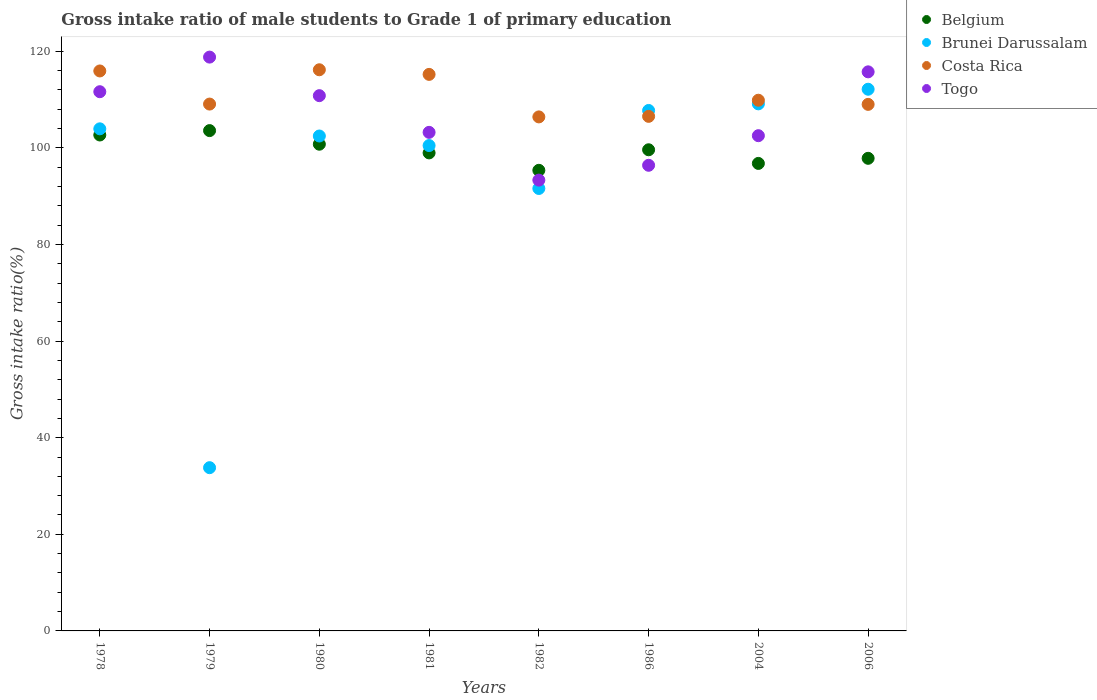Is the number of dotlines equal to the number of legend labels?
Ensure brevity in your answer.  Yes. What is the gross intake ratio in Costa Rica in 1979?
Your answer should be very brief. 109.07. Across all years, what is the maximum gross intake ratio in Belgium?
Make the answer very short. 103.58. Across all years, what is the minimum gross intake ratio in Costa Rica?
Give a very brief answer. 106.41. What is the total gross intake ratio in Togo in the graph?
Provide a short and direct response. 852.44. What is the difference between the gross intake ratio in Brunei Darussalam in 1980 and that in 2004?
Your answer should be compact. -6.66. What is the difference between the gross intake ratio in Togo in 1979 and the gross intake ratio in Belgium in 1986?
Your answer should be compact. 19.19. What is the average gross intake ratio in Togo per year?
Offer a terse response. 106.55. In the year 1979, what is the difference between the gross intake ratio in Togo and gross intake ratio in Brunei Darussalam?
Give a very brief answer. 85. What is the ratio of the gross intake ratio in Belgium in 1986 to that in 2004?
Give a very brief answer. 1.03. Is the difference between the gross intake ratio in Togo in 1982 and 2004 greater than the difference between the gross intake ratio in Brunei Darussalam in 1982 and 2004?
Provide a succinct answer. Yes. What is the difference between the highest and the second highest gross intake ratio in Togo?
Offer a terse response. 3.05. What is the difference between the highest and the lowest gross intake ratio in Brunei Darussalam?
Your response must be concise. 78.34. In how many years, is the gross intake ratio in Costa Rica greater than the average gross intake ratio in Costa Rica taken over all years?
Offer a very short reply. 3. Is the sum of the gross intake ratio in Costa Rica in 1979 and 1986 greater than the maximum gross intake ratio in Brunei Darussalam across all years?
Offer a very short reply. Yes. Is it the case that in every year, the sum of the gross intake ratio in Belgium and gross intake ratio in Togo  is greater than the sum of gross intake ratio in Brunei Darussalam and gross intake ratio in Costa Rica?
Offer a terse response. No. Does the gross intake ratio in Belgium monotonically increase over the years?
Your response must be concise. No. Is the gross intake ratio in Brunei Darussalam strictly less than the gross intake ratio in Belgium over the years?
Provide a short and direct response. No. How many dotlines are there?
Provide a short and direct response. 4. What is the difference between two consecutive major ticks on the Y-axis?
Provide a short and direct response. 20. What is the title of the graph?
Provide a succinct answer. Gross intake ratio of male students to Grade 1 of primary education. What is the label or title of the Y-axis?
Give a very brief answer. Gross intake ratio(%). What is the Gross intake ratio(%) of Belgium in 1978?
Your response must be concise. 102.67. What is the Gross intake ratio(%) of Brunei Darussalam in 1978?
Your answer should be very brief. 103.94. What is the Gross intake ratio(%) in Costa Rica in 1978?
Your answer should be very brief. 115.93. What is the Gross intake ratio(%) of Togo in 1978?
Provide a short and direct response. 111.63. What is the Gross intake ratio(%) of Belgium in 1979?
Offer a very short reply. 103.58. What is the Gross intake ratio(%) in Brunei Darussalam in 1979?
Give a very brief answer. 33.8. What is the Gross intake ratio(%) in Costa Rica in 1979?
Make the answer very short. 109.07. What is the Gross intake ratio(%) of Togo in 1979?
Your response must be concise. 118.79. What is the Gross intake ratio(%) in Belgium in 1980?
Provide a short and direct response. 100.76. What is the Gross intake ratio(%) of Brunei Darussalam in 1980?
Your response must be concise. 102.46. What is the Gross intake ratio(%) of Costa Rica in 1980?
Keep it short and to the point. 116.17. What is the Gross intake ratio(%) in Togo in 1980?
Offer a terse response. 110.81. What is the Gross intake ratio(%) in Belgium in 1981?
Offer a terse response. 98.96. What is the Gross intake ratio(%) of Brunei Darussalam in 1981?
Your answer should be compact. 100.48. What is the Gross intake ratio(%) in Costa Rica in 1981?
Your answer should be compact. 115.21. What is the Gross intake ratio(%) of Togo in 1981?
Keep it short and to the point. 103.21. What is the Gross intake ratio(%) of Belgium in 1982?
Offer a terse response. 95.36. What is the Gross intake ratio(%) in Brunei Darussalam in 1982?
Ensure brevity in your answer.  91.6. What is the Gross intake ratio(%) of Costa Rica in 1982?
Offer a very short reply. 106.41. What is the Gross intake ratio(%) in Togo in 1982?
Provide a short and direct response. 93.33. What is the Gross intake ratio(%) of Belgium in 1986?
Make the answer very short. 99.61. What is the Gross intake ratio(%) of Brunei Darussalam in 1986?
Your response must be concise. 107.75. What is the Gross intake ratio(%) of Costa Rica in 1986?
Give a very brief answer. 106.53. What is the Gross intake ratio(%) in Togo in 1986?
Your answer should be compact. 96.4. What is the Gross intake ratio(%) in Belgium in 2004?
Provide a succinct answer. 96.78. What is the Gross intake ratio(%) in Brunei Darussalam in 2004?
Keep it short and to the point. 109.11. What is the Gross intake ratio(%) of Costa Rica in 2004?
Your answer should be very brief. 109.86. What is the Gross intake ratio(%) of Togo in 2004?
Offer a terse response. 102.52. What is the Gross intake ratio(%) of Belgium in 2006?
Offer a very short reply. 97.84. What is the Gross intake ratio(%) in Brunei Darussalam in 2006?
Offer a very short reply. 112.14. What is the Gross intake ratio(%) in Costa Rica in 2006?
Make the answer very short. 109.01. What is the Gross intake ratio(%) of Togo in 2006?
Ensure brevity in your answer.  115.74. Across all years, what is the maximum Gross intake ratio(%) in Belgium?
Offer a very short reply. 103.58. Across all years, what is the maximum Gross intake ratio(%) in Brunei Darussalam?
Ensure brevity in your answer.  112.14. Across all years, what is the maximum Gross intake ratio(%) of Costa Rica?
Ensure brevity in your answer.  116.17. Across all years, what is the maximum Gross intake ratio(%) of Togo?
Provide a short and direct response. 118.79. Across all years, what is the minimum Gross intake ratio(%) in Belgium?
Your response must be concise. 95.36. Across all years, what is the minimum Gross intake ratio(%) in Brunei Darussalam?
Provide a succinct answer. 33.8. Across all years, what is the minimum Gross intake ratio(%) in Costa Rica?
Offer a terse response. 106.41. Across all years, what is the minimum Gross intake ratio(%) of Togo?
Offer a terse response. 93.33. What is the total Gross intake ratio(%) of Belgium in the graph?
Provide a short and direct response. 795.55. What is the total Gross intake ratio(%) in Brunei Darussalam in the graph?
Provide a succinct answer. 761.27. What is the total Gross intake ratio(%) of Costa Rica in the graph?
Your answer should be compact. 888.19. What is the total Gross intake ratio(%) of Togo in the graph?
Your answer should be compact. 852.44. What is the difference between the Gross intake ratio(%) of Belgium in 1978 and that in 1979?
Your answer should be compact. -0.91. What is the difference between the Gross intake ratio(%) in Brunei Darussalam in 1978 and that in 1979?
Your response must be concise. 70.15. What is the difference between the Gross intake ratio(%) of Costa Rica in 1978 and that in 1979?
Ensure brevity in your answer.  6.86. What is the difference between the Gross intake ratio(%) of Togo in 1978 and that in 1979?
Offer a terse response. -7.17. What is the difference between the Gross intake ratio(%) in Belgium in 1978 and that in 1980?
Offer a very short reply. 1.91. What is the difference between the Gross intake ratio(%) in Brunei Darussalam in 1978 and that in 1980?
Your answer should be very brief. 1.49. What is the difference between the Gross intake ratio(%) of Costa Rica in 1978 and that in 1980?
Your answer should be very brief. -0.25. What is the difference between the Gross intake ratio(%) of Togo in 1978 and that in 1980?
Your response must be concise. 0.82. What is the difference between the Gross intake ratio(%) in Belgium in 1978 and that in 1981?
Provide a succinct answer. 3.71. What is the difference between the Gross intake ratio(%) in Brunei Darussalam in 1978 and that in 1981?
Your answer should be very brief. 3.46. What is the difference between the Gross intake ratio(%) in Costa Rica in 1978 and that in 1981?
Provide a short and direct response. 0.71. What is the difference between the Gross intake ratio(%) in Togo in 1978 and that in 1981?
Your response must be concise. 8.41. What is the difference between the Gross intake ratio(%) of Belgium in 1978 and that in 1982?
Provide a succinct answer. 7.31. What is the difference between the Gross intake ratio(%) in Brunei Darussalam in 1978 and that in 1982?
Your answer should be compact. 12.35. What is the difference between the Gross intake ratio(%) in Costa Rica in 1978 and that in 1982?
Your answer should be compact. 9.51. What is the difference between the Gross intake ratio(%) of Togo in 1978 and that in 1982?
Your response must be concise. 18.3. What is the difference between the Gross intake ratio(%) of Belgium in 1978 and that in 1986?
Keep it short and to the point. 3.06. What is the difference between the Gross intake ratio(%) in Brunei Darussalam in 1978 and that in 1986?
Offer a terse response. -3.8. What is the difference between the Gross intake ratio(%) of Costa Rica in 1978 and that in 1986?
Your answer should be very brief. 9.4. What is the difference between the Gross intake ratio(%) of Togo in 1978 and that in 1986?
Offer a very short reply. 15.23. What is the difference between the Gross intake ratio(%) of Belgium in 1978 and that in 2004?
Your answer should be compact. 5.89. What is the difference between the Gross intake ratio(%) of Brunei Darussalam in 1978 and that in 2004?
Ensure brevity in your answer.  -5.17. What is the difference between the Gross intake ratio(%) in Costa Rica in 1978 and that in 2004?
Keep it short and to the point. 6.06. What is the difference between the Gross intake ratio(%) of Togo in 1978 and that in 2004?
Ensure brevity in your answer.  9.1. What is the difference between the Gross intake ratio(%) of Belgium in 1978 and that in 2006?
Make the answer very short. 4.83. What is the difference between the Gross intake ratio(%) of Brunei Darussalam in 1978 and that in 2006?
Ensure brevity in your answer.  -8.2. What is the difference between the Gross intake ratio(%) in Costa Rica in 1978 and that in 2006?
Provide a short and direct response. 6.92. What is the difference between the Gross intake ratio(%) in Togo in 1978 and that in 2006?
Offer a very short reply. -4.11. What is the difference between the Gross intake ratio(%) in Belgium in 1979 and that in 1980?
Ensure brevity in your answer.  2.82. What is the difference between the Gross intake ratio(%) of Brunei Darussalam in 1979 and that in 1980?
Your answer should be very brief. -68.66. What is the difference between the Gross intake ratio(%) of Costa Rica in 1979 and that in 1980?
Make the answer very short. -7.1. What is the difference between the Gross intake ratio(%) in Togo in 1979 and that in 1980?
Offer a very short reply. 7.98. What is the difference between the Gross intake ratio(%) in Belgium in 1979 and that in 1981?
Your answer should be compact. 4.61. What is the difference between the Gross intake ratio(%) of Brunei Darussalam in 1979 and that in 1981?
Make the answer very short. -66.69. What is the difference between the Gross intake ratio(%) in Costa Rica in 1979 and that in 1981?
Your response must be concise. -6.14. What is the difference between the Gross intake ratio(%) of Togo in 1979 and that in 1981?
Make the answer very short. 15.58. What is the difference between the Gross intake ratio(%) in Belgium in 1979 and that in 1982?
Your response must be concise. 8.22. What is the difference between the Gross intake ratio(%) in Brunei Darussalam in 1979 and that in 1982?
Offer a terse response. -57.8. What is the difference between the Gross intake ratio(%) of Costa Rica in 1979 and that in 1982?
Ensure brevity in your answer.  2.66. What is the difference between the Gross intake ratio(%) in Togo in 1979 and that in 1982?
Your response must be concise. 25.47. What is the difference between the Gross intake ratio(%) in Belgium in 1979 and that in 1986?
Your response must be concise. 3.97. What is the difference between the Gross intake ratio(%) of Brunei Darussalam in 1979 and that in 1986?
Give a very brief answer. -73.95. What is the difference between the Gross intake ratio(%) in Costa Rica in 1979 and that in 1986?
Offer a very short reply. 2.54. What is the difference between the Gross intake ratio(%) in Togo in 1979 and that in 1986?
Your answer should be very brief. 22.4. What is the difference between the Gross intake ratio(%) in Belgium in 1979 and that in 2004?
Offer a very short reply. 6.79. What is the difference between the Gross intake ratio(%) in Brunei Darussalam in 1979 and that in 2004?
Provide a short and direct response. -75.32. What is the difference between the Gross intake ratio(%) of Costa Rica in 1979 and that in 2004?
Your answer should be compact. -0.8. What is the difference between the Gross intake ratio(%) in Togo in 1979 and that in 2004?
Provide a succinct answer. 16.27. What is the difference between the Gross intake ratio(%) of Belgium in 1979 and that in 2006?
Give a very brief answer. 5.74. What is the difference between the Gross intake ratio(%) of Brunei Darussalam in 1979 and that in 2006?
Your response must be concise. -78.34. What is the difference between the Gross intake ratio(%) of Costa Rica in 1979 and that in 2006?
Make the answer very short. 0.06. What is the difference between the Gross intake ratio(%) of Togo in 1979 and that in 2006?
Make the answer very short. 3.05. What is the difference between the Gross intake ratio(%) of Belgium in 1980 and that in 1981?
Give a very brief answer. 1.8. What is the difference between the Gross intake ratio(%) of Brunei Darussalam in 1980 and that in 1981?
Provide a short and direct response. 1.98. What is the difference between the Gross intake ratio(%) in Costa Rica in 1980 and that in 1981?
Offer a terse response. 0.96. What is the difference between the Gross intake ratio(%) in Togo in 1980 and that in 1981?
Your response must be concise. 7.6. What is the difference between the Gross intake ratio(%) of Belgium in 1980 and that in 1982?
Provide a succinct answer. 5.4. What is the difference between the Gross intake ratio(%) of Brunei Darussalam in 1980 and that in 1982?
Offer a very short reply. 10.86. What is the difference between the Gross intake ratio(%) in Costa Rica in 1980 and that in 1982?
Make the answer very short. 9.76. What is the difference between the Gross intake ratio(%) of Togo in 1980 and that in 1982?
Make the answer very short. 17.49. What is the difference between the Gross intake ratio(%) in Belgium in 1980 and that in 1986?
Your answer should be compact. 1.15. What is the difference between the Gross intake ratio(%) in Brunei Darussalam in 1980 and that in 1986?
Give a very brief answer. -5.29. What is the difference between the Gross intake ratio(%) of Costa Rica in 1980 and that in 1986?
Keep it short and to the point. 9.64. What is the difference between the Gross intake ratio(%) in Togo in 1980 and that in 1986?
Offer a terse response. 14.41. What is the difference between the Gross intake ratio(%) of Belgium in 1980 and that in 2004?
Keep it short and to the point. 3.98. What is the difference between the Gross intake ratio(%) in Brunei Darussalam in 1980 and that in 2004?
Offer a terse response. -6.66. What is the difference between the Gross intake ratio(%) of Costa Rica in 1980 and that in 2004?
Provide a short and direct response. 6.31. What is the difference between the Gross intake ratio(%) of Togo in 1980 and that in 2004?
Offer a terse response. 8.29. What is the difference between the Gross intake ratio(%) in Belgium in 1980 and that in 2006?
Make the answer very short. 2.92. What is the difference between the Gross intake ratio(%) in Brunei Darussalam in 1980 and that in 2006?
Give a very brief answer. -9.68. What is the difference between the Gross intake ratio(%) in Costa Rica in 1980 and that in 2006?
Provide a short and direct response. 7.16. What is the difference between the Gross intake ratio(%) in Togo in 1980 and that in 2006?
Make the answer very short. -4.93. What is the difference between the Gross intake ratio(%) of Belgium in 1981 and that in 1982?
Make the answer very short. 3.61. What is the difference between the Gross intake ratio(%) in Brunei Darussalam in 1981 and that in 1982?
Keep it short and to the point. 8.89. What is the difference between the Gross intake ratio(%) in Costa Rica in 1981 and that in 1982?
Your answer should be compact. 8.8. What is the difference between the Gross intake ratio(%) in Togo in 1981 and that in 1982?
Offer a terse response. 9.89. What is the difference between the Gross intake ratio(%) in Belgium in 1981 and that in 1986?
Give a very brief answer. -0.65. What is the difference between the Gross intake ratio(%) of Brunei Darussalam in 1981 and that in 1986?
Your answer should be compact. -7.27. What is the difference between the Gross intake ratio(%) of Costa Rica in 1981 and that in 1986?
Your answer should be compact. 8.69. What is the difference between the Gross intake ratio(%) of Togo in 1981 and that in 1986?
Your answer should be very brief. 6.82. What is the difference between the Gross intake ratio(%) of Belgium in 1981 and that in 2004?
Make the answer very short. 2.18. What is the difference between the Gross intake ratio(%) in Brunei Darussalam in 1981 and that in 2004?
Provide a succinct answer. -8.63. What is the difference between the Gross intake ratio(%) in Costa Rica in 1981 and that in 2004?
Offer a very short reply. 5.35. What is the difference between the Gross intake ratio(%) of Togo in 1981 and that in 2004?
Your answer should be compact. 0.69. What is the difference between the Gross intake ratio(%) of Belgium in 1981 and that in 2006?
Offer a terse response. 1.12. What is the difference between the Gross intake ratio(%) of Brunei Darussalam in 1981 and that in 2006?
Make the answer very short. -11.66. What is the difference between the Gross intake ratio(%) of Costa Rica in 1981 and that in 2006?
Provide a succinct answer. 6.21. What is the difference between the Gross intake ratio(%) in Togo in 1981 and that in 2006?
Give a very brief answer. -12.53. What is the difference between the Gross intake ratio(%) in Belgium in 1982 and that in 1986?
Keep it short and to the point. -4.25. What is the difference between the Gross intake ratio(%) in Brunei Darussalam in 1982 and that in 1986?
Your answer should be compact. -16.15. What is the difference between the Gross intake ratio(%) in Costa Rica in 1982 and that in 1986?
Your response must be concise. -0.11. What is the difference between the Gross intake ratio(%) of Togo in 1982 and that in 1986?
Offer a very short reply. -3.07. What is the difference between the Gross intake ratio(%) of Belgium in 1982 and that in 2004?
Give a very brief answer. -1.43. What is the difference between the Gross intake ratio(%) of Brunei Darussalam in 1982 and that in 2004?
Your answer should be compact. -17.52. What is the difference between the Gross intake ratio(%) of Costa Rica in 1982 and that in 2004?
Your answer should be compact. -3.45. What is the difference between the Gross intake ratio(%) of Togo in 1982 and that in 2004?
Ensure brevity in your answer.  -9.2. What is the difference between the Gross intake ratio(%) in Belgium in 1982 and that in 2006?
Your answer should be very brief. -2.48. What is the difference between the Gross intake ratio(%) in Brunei Darussalam in 1982 and that in 2006?
Give a very brief answer. -20.55. What is the difference between the Gross intake ratio(%) of Costa Rica in 1982 and that in 2006?
Keep it short and to the point. -2.59. What is the difference between the Gross intake ratio(%) of Togo in 1982 and that in 2006?
Your answer should be very brief. -22.42. What is the difference between the Gross intake ratio(%) in Belgium in 1986 and that in 2004?
Your answer should be very brief. 2.82. What is the difference between the Gross intake ratio(%) in Brunei Darussalam in 1986 and that in 2004?
Make the answer very short. -1.37. What is the difference between the Gross intake ratio(%) in Costa Rica in 1986 and that in 2004?
Ensure brevity in your answer.  -3.34. What is the difference between the Gross intake ratio(%) of Togo in 1986 and that in 2004?
Provide a succinct answer. -6.13. What is the difference between the Gross intake ratio(%) in Belgium in 1986 and that in 2006?
Your answer should be very brief. 1.77. What is the difference between the Gross intake ratio(%) of Brunei Darussalam in 1986 and that in 2006?
Make the answer very short. -4.39. What is the difference between the Gross intake ratio(%) of Costa Rica in 1986 and that in 2006?
Keep it short and to the point. -2.48. What is the difference between the Gross intake ratio(%) of Togo in 1986 and that in 2006?
Your answer should be compact. -19.34. What is the difference between the Gross intake ratio(%) of Belgium in 2004 and that in 2006?
Give a very brief answer. -1.06. What is the difference between the Gross intake ratio(%) of Brunei Darussalam in 2004 and that in 2006?
Your answer should be very brief. -3.03. What is the difference between the Gross intake ratio(%) in Costa Rica in 2004 and that in 2006?
Your answer should be compact. 0.86. What is the difference between the Gross intake ratio(%) of Togo in 2004 and that in 2006?
Make the answer very short. -13.22. What is the difference between the Gross intake ratio(%) in Belgium in 1978 and the Gross intake ratio(%) in Brunei Darussalam in 1979?
Keep it short and to the point. 68.87. What is the difference between the Gross intake ratio(%) of Belgium in 1978 and the Gross intake ratio(%) of Costa Rica in 1979?
Offer a terse response. -6.4. What is the difference between the Gross intake ratio(%) of Belgium in 1978 and the Gross intake ratio(%) of Togo in 1979?
Ensure brevity in your answer.  -16.12. What is the difference between the Gross intake ratio(%) in Brunei Darussalam in 1978 and the Gross intake ratio(%) in Costa Rica in 1979?
Your response must be concise. -5.13. What is the difference between the Gross intake ratio(%) of Brunei Darussalam in 1978 and the Gross intake ratio(%) of Togo in 1979?
Offer a very short reply. -14.85. What is the difference between the Gross intake ratio(%) of Costa Rica in 1978 and the Gross intake ratio(%) of Togo in 1979?
Offer a very short reply. -2.87. What is the difference between the Gross intake ratio(%) of Belgium in 1978 and the Gross intake ratio(%) of Brunei Darussalam in 1980?
Keep it short and to the point. 0.21. What is the difference between the Gross intake ratio(%) in Belgium in 1978 and the Gross intake ratio(%) in Costa Rica in 1980?
Keep it short and to the point. -13.5. What is the difference between the Gross intake ratio(%) of Belgium in 1978 and the Gross intake ratio(%) of Togo in 1980?
Provide a short and direct response. -8.14. What is the difference between the Gross intake ratio(%) in Brunei Darussalam in 1978 and the Gross intake ratio(%) in Costa Rica in 1980?
Offer a terse response. -12.23. What is the difference between the Gross intake ratio(%) of Brunei Darussalam in 1978 and the Gross intake ratio(%) of Togo in 1980?
Offer a very short reply. -6.87. What is the difference between the Gross intake ratio(%) of Costa Rica in 1978 and the Gross intake ratio(%) of Togo in 1980?
Make the answer very short. 5.11. What is the difference between the Gross intake ratio(%) in Belgium in 1978 and the Gross intake ratio(%) in Brunei Darussalam in 1981?
Keep it short and to the point. 2.19. What is the difference between the Gross intake ratio(%) of Belgium in 1978 and the Gross intake ratio(%) of Costa Rica in 1981?
Your answer should be compact. -12.55. What is the difference between the Gross intake ratio(%) of Belgium in 1978 and the Gross intake ratio(%) of Togo in 1981?
Your answer should be very brief. -0.55. What is the difference between the Gross intake ratio(%) in Brunei Darussalam in 1978 and the Gross intake ratio(%) in Costa Rica in 1981?
Your answer should be compact. -11.27. What is the difference between the Gross intake ratio(%) of Brunei Darussalam in 1978 and the Gross intake ratio(%) of Togo in 1981?
Your response must be concise. 0.73. What is the difference between the Gross intake ratio(%) in Costa Rica in 1978 and the Gross intake ratio(%) in Togo in 1981?
Offer a very short reply. 12.71. What is the difference between the Gross intake ratio(%) in Belgium in 1978 and the Gross intake ratio(%) in Brunei Darussalam in 1982?
Give a very brief answer. 11.07. What is the difference between the Gross intake ratio(%) of Belgium in 1978 and the Gross intake ratio(%) of Costa Rica in 1982?
Provide a succinct answer. -3.74. What is the difference between the Gross intake ratio(%) in Belgium in 1978 and the Gross intake ratio(%) in Togo in 1982?
Give a very brief answer. 9.34. What is the difference between the Gross intake ratio(%) of Brunei Darussalam in 1978 and the Gross intake ratio(%) of Costa Rica in 1982?
Offer a terse response. -2.47. What is the difference between the Gross intake ratio(%) in Brunei Darussalam in 1978 and the Gross intake ratio(%) in Togo in 1982?
Provide a succinct answer. 10.62. What is the difference between the Gross intake ratio(%) in Costa Rica in 1978 and the Gross intake ratio(%) in Togo in 1982?
Keep it short and to the point. 22.6. What is the difference between the Gross intake ratio(%) of Belgium in 1978 and the Gross intake ratio(%) of Brunei Darussalam in 1986?
Make the answer very short. -5.08. What is the difference between the Gross intake ratio(%) of Belgium in 1978 and the Gross intake ratio(%) of Costa Rica in 1986?
Your answer should be compact. -3.86. What is the difference between the Gross intake ratio(%) in Belgium in 1978 and the Gross intake ratio(%) in Togo in 1986?
Your answer should be compact. 6.27. What is the difference between the Gross intake ratio(%) in Brunei Darussalam in 1978 and the Gross intake ratio(%) in Costa Rica in 1986?
Your answer should be very brief. -2.58. What is the difference between the Gross intake ratio(%) in Brunei Darussalam in 1978 and the Gross intake ratio(%) in Togo in 1986?
Your answer should be very brief. 7.55. What is the difference between the Gross intake ratio(%) of Costa Rica in 1978 and the Gross intake ratio(%) of Togo in 1986?
Provide a succinct answer. 19.53. What is the difference between the Gross intake ratio(%) in Belgium in 1978 and the Gross intake ratio(%) in Brunei Darussalam in 2004?
Offer a very short reply. -6.44. What is the difference between the Gross intake ratio(%) of Belgium in 1978 and the Gross intake ratio(%) of Costa Rica in 2004?
Provide a short and direct response. -7.2. What is the difference between the Gross intake ratio(%) of Belgium in 1978 and the Gross intake ratio(%) of Togo in 2004?
Give a very brief answer. 0.14. What is the difference between the Gross intake ratio(%) in Brunei Darussalam in 1978 and the Gross intake ratio(%) in Costa Rica in 2004?
Ensure brevity in your answer.  -5.92. What is the difference between the Gross intake ratio(%) in Brunei Darussalam in 1978 and the Gross intake ratio(%) in Togo in 2004?
Your answer should be compact. 1.42. What is the difference between the Gross intake ratio(%) in Costa Rica in 1978 and the Gross intake ratio(%) in Togo in 2004?
Offer a very short reply. 13.4. What is the difference between the Gross intake ratio(%) in Belgium in 1978 and the Gross intake ratio(%) in Brunei Darussalam in 2006?
Keep it short and to the point. -9.47. What is the difference between the Gross intake ratio(%) in Belgium in 1978 and the Gross intake ratio(%) in Costa Rica in 2006?
Your answer should be compact. -6.34. What is the difference between the Gross intake ratio(%) in Belgium in 1978 and the Gross intake ratio(%) in Togo in 2006?
Your answer should be very brief. -13.07. What is the difference between the Gross intake ratio(%) in Brunei Darussalam in 1978 and the Gross intake ratio(%) in Costa Rica in 2006?
Your response must be concise. -5.06. What is the difference between the Gross intake ratio(%) of Brunei Darussalam in 1978 and the Gross intake ratio(%) of Togo in 2006?
Provide a short and direct response. -11.8. What is the difference between the Gross intake ratio(%) in Costa Rica in 1978 and the Gross intake ratio(%) in Togo in 2006?
Offer a terse response. 0.18. What is the difference between the Gross intake ratio(%) of Belgium in 1979 and the Gross intake ratio(%) of Brunei Darussalam in 1980?
Provide a succinct answer. 1.12. What is the difference between the Gross intake ratio(%) of Belgium in 1979 and the Gross intake ratio(%) of Costa Rica in 1980?
Provide a succinct answer. -12.59. What is the difference between the Gross intake ratio(%) in Belgium in 1979 and the Gross intake ratio(%) in Togo in 1980?
Provide a short and direct response. -7.23. What is the difference between the Gross intake ratio(%) of Brunei Darussalam in 1979 and the Gross intake ratio(%) of Costa Rica in 1980?
Offer a very short reply. -82.38. What is the difference between the Gross intake ratio(%) in Brunei Darussalam in 1979 and the Gross intake ratio(%) in Togo in 1980?
Provide a short and direct response. -77.02. What is the difference between the Gross intake ratio(%) in Costa Rica in 1979 and the Gross intake ratio(%) in Togo in 1980?
Offer a very short reply. -1.74. What is the difference between the Gross intake ratio(%) in Belgium in 1979 and the Gross intake ratio(%) in Brunei Darussalam in 1981?
Give a very brief answer. 3.1. What is the difference between the Gross intake ratio(%) of Belgium in 1979 and the Gross intake ratio(%) of Costa Rica in 1981?
Offer a terse response. -11.64. What is the difference between the Gross intake ratio(%) in Belgium in 1979 and the Gross intake ratio(%) in Togo in 1981?
Offer a terse response. 0.36. What is the difference between the Gross intake ratio(%) of Brunei Darussalam in 1979 and the Gross intake ratio(%) of Costa Rica in 1981?
Make the answer very short. -81.42. What is the difference between the Gross intake ratio(%) of Brunei Darussalam in 1979 and the Gross intake ratio(%) of Togo in 1981?
Keep it short and to the point. -69.42. What is the difference between the Gross intake ratio(%) in Costa Rica in 1979 and the Gross intake ratio(%) in Togo in 1981?
Ensure brevity in your answer.  5.85. What is the difference between the Gross intake ratio(%) of Belgium in 1979 and the Gross intake ratio(%) of Brunei Darussalam in 1982?
Your answer should be very brief. 11.98. What is the difference between the Gross intake ratio(%) of Belgium in 1979 and the Gross intake ratio(%) of Costa Rica in 1982?
Provide a succinct answer. -2.84. What is the difference between the Gross intake ratio(%) of Belgium in 1979 and the Gross intake ratio(%) of Togo in 1982?
Make the answer very short. 10.25. What is the difference between the Gross intake ratio(%) of Brunei Darussalam in 1979 and the Gross intake ratio(%) of Costa Rica in 1982?
Offer a terse response. -72.62. What is the difference between the Gross intake ratio(%) in Brunei Darussalam in 1979 and the Gross intake ratio(%) in Togo in 1982?
Make the answer very short. -59.53. What is the difference between the Gross intake ratio(%) of Costa Rica in 1979 and the Gross intake ratio(%) of Togo in 1982?
Your answer should be very brief. 15.74. What is the difference between the Gross intake ratio(%) in Belgium in 1979 and the Gross intake ratio(%) in Brunei Darussalam in 1986?
Your answer should be compact. -4.17. What is the difference between the Gross intake ratio(%) of Belgium in 1979 and the Gross intake ratio(%) of Costa Rica in 1986?
Ensure brevity in your answer.  -2.95. What is the difference between the Gross intake ratio(%) in Belgium in 1979 and the Gross intake ratio(%) in Togo in 1986?
Provide a succinct answer. 7.18. What is the difference between the Gross intake ratio(%) in Brunei Darussalam in 1979 and the Gross intake ratio(%) in Costa Rica in 1986?
Offer a terse response. -72.73. What is the difference between the Gross intake ratio(%) in Brunei Darussalam in 1979 and the Gross intake ratio(%) in Togo in 1986?
Your answer should be compact. -62.6. What is the difference between the Gross intake ratio(%) of Costa Rica in 1979 and the Gross intake ratio(%) of Togo in 1986?
Provide a succinct answer. 12.67. What is the difference between the Gross intake ratio(%) in Belgium in 1979 and the Gross intake ratio(%) in Brunei Darussalam in 2004?
Your answer should be very brief. -5.54. What is the difference between the Gross intake ratio(%) in Belgium in 1979 and the Gross intake ratio(%) in Costa Rica in 2004?
Give a very brief answer. -6.29. What is the difference between the Gross intake ratio(%) in Belgium in 1979 and the Gross intake ratio(%) in Togo in 2004?
Provide a short and direct response. 1.05. What is the difference between the Gross intake ratio(%) of Brunei Darussalam in 1979 and the Gross intake ratio(%) of Costa Rica in 2004?
Provide a succinct answer. -76.07. What is the difference between the Gross intake ratio(%) of Brunei Darussalam in 1979 and the Gross intake ratio(%) of Togo in 2004?
Your response must be concise. -68.73. What is the difference between the Gross intake ratio(%) in Costa Rica in 1979 and the Gross intake ratio(%) in Togo in 2004?
Keep it short and to the point. 6.54. What is the difference between the Gross intake ratio(%) in Belgium in 1979 and the Gross intake ratio(%) in Brunei Darussalam in 2006?
Offer a very short reply. -8.56. What is the difference between the Gross intake ratio(%) of Belgium in 1979 and the Gross intake ratio(%) of Costa Rica in 2006?
Provide a short and direct response. -5.43. What is the difference between the Gross intake ratio(%) of Belgium in 1979 and the Gross intake ratio(%) of Togo in 2006?
Provide a short and direct response. -12.16. What is the difference between the Gross intake ratio(%) of Brunei Darussalam in 1979 and the Gross intake ratio(%) of Costa Rica in 2006?
Provide a succinct answer. -75.21. What is the difference between the Gross intake ratio(%) in Brunei Darussalam in 1979 and the Gross intake ratio(%) in Togo in 2006?
Your answer should be compact. -81.95. What is the difference between the Gross intake ratio(%) in Costa Rica in 1979 and the Gross intake ratio(%) in Togo in 2006?
Your answer should be very brief. -6.67. What is the difference between the Gross intake ratio(%) in Belgium in 1980 and the Gross intake ratio(%) in Brunei Darussalam in 1981?
Make the answer very short. 0.28. What is the difference between the Gross intake ratio(%) in Belgium in 1980 and the Gross intake ratio(%) in Costa Rica in 1981?
Offer a terse response. -14.45. What is the difference between the Gross intake ratio(%) of Belgium in 1980 and the Gross intake ratio(%) of Togo in 1981?
Your response must be concise. -2.46. What is the difference between the Gross intake ratio(%) of Brunei Darussalam in 1980 and the Gross intake ratio(%) of Costa Rica in 1981?
Your answer should be very brief. -12.76. What is the difference between the Gross intake ratio(%) in Brunei Darussalam in 1980 and the Gross intake ratio(%) in Togo in 1981?
Offer a terse response. -0.76. What is the difference between the Gross intake ratio(%) of Costa Rica in 1980 and the Gross intake ratio(%) of Togo in 1981?
Offer a very short reply. 12.96. What is the difference between the Gross intake ratio(%) of Belgium in 1980 and the Gross intake ratio(%) of Brunei Darussalam in 1982?
Your answer should be very brief. 9.16. What is the difference between the Gross intake ratio(%) in Belgium in 1980 and the Gross intake ratio(%) in Costa Rica in 1982?
Your answer should be very brief. -5.65. What is the difference between the Gross intake ratio(%) of Belgium in 1980 and the Gross intake ratio(%) of Togo in 1982?
Your answer should be very brief. 7.43. What is the difference between the Gross intake ratio(%) of Brunei Darussalam in 1980 and the Gross intake ratio(%) of Costa Rica in 1982?
Your answer should be very brief. -3.95. What is the difference between the Gross intake ratio(%) in Brunei Darussalam in 1980 and the Gross intake ratio(%) in Togo in 1982?
Give a very brief answer. 9.13. What is the difference between the Gross intake ratio(%) of Costa Rica in 1980 and the Gross intake ratio(%) of Togo in 1982?
Your answer should be very brief. 22.84. What is the difference between the Gross intake ratio(%) of Belgium in 1980 and the Gross intake ratio(%) of Brunei Darussalam in 1986?
Give a very brief answer. -6.99. What is the difference between the Gross intake ratio(%) of Belgium in 1980 and the Gross intake ratio(%) of Costa Rica in 1986?
Your answer should be very brief. -5.77. What is the difference between the Gross intake ratio(%) of Belgium in 1980 and the Gross intake ratio(%) of Togo in 1986?
Offer a very short reply. 4.36. What is the difference between the Gross intake ratio(%) of Brunei Darussalam in 1980 and the Gross intake ratio(%) of Costa Rica in 1986?
Give a very brief answer. -4.07. What is the difference between the Gross intake ratio(%) of Brunei Darussalam in 1980 and the Gross intake ratio(%) of Togo in 1986?
Provide a succinct answer. 6.06. What is the difference between the Gross intake ratio(%) of Costa Rica in 1980 and the Gross intake ratio(%) of Togo in 1986?
Your response must be concise. 19.77. What is the difference between the Gross intake ratio(%) of Belgium in 1980 and the Gross intake ratio(%) of Brunei Darussalam in 2004?
Keep it short and to the point. -8.35. What is the difference between the Gross intake ratio(%) in Belgium in 1980 and the Gross intake ratio(%) in Costa Rica in 2004?
Make the answer very short. -9.1. What is the difference between the Gross intake ratio(%) in Belgium in 1980 and the Gross intake ratio(%) in Togo in 2004?
Give a very brief answer. -1.76. What is the difference between the Gross intake ratio(%) in Brunei Darussalam in 1980 and the Gross intake ratio(%) in Costa Rica in 2004?
Your answer should be very brief. -7.41. What is the difference between the Gross intake ratio(%) of Brunei Darussalam in 1980 and the Gross intake ratio(%) of Togo in 2004?
Keep it short and to the point. -0.07. What is the difference between the Gross intake ratio(%) of Costa Rica in 1980 and the Gross intake ratio(%) of Togo in 2004?
Ensure brevity in your answer.  13.65. What is the difference between the Gross intake ratio(%) of Belgium in 1980 and the Gross intake ratio(%) of Brunei Darussalam in 2006?
Your response must be concise. -11.38. What is the difference between the Gross intake ratio(%) of Belgium in 1980 and the Gross intake ratio(%) of Costa Rica in 2006?
Your answer should be very brief. -8.25. What is the difference between the Gross intake ratio(%) in Belgium in 1980 and the Gross intake ratio(%) in Togo in 2006?
Your answer should be very brief. -14.98. What is the difference between the Gross intake ratio(%) of Brunei Darussalam in 1980 and the Gross intake ratio(%) of Costa Rica in 2006?
Provide a short and direct response. -6.55. What is the difference between the Gross intake ratio(%) in Brunei Darussalam in 1980 and the Gross intake ratio(%) in Togo in 2006?
Your answer should be very brief. -13.28. What is the difference between the Gross intake ratio(%) in Costa Rica in 1980 and the Gross intake ratio(%) in Togo in 2006?
Your answer should be compact. 0.43. What is the difference between the Gross intake ratio(%) in Belgium in 1981 and the Gross intake ratio(%) in Brunei Darussalam in 1982?
Make the answer very short. 7.37. What is the difference between the Gross intake ratio(%) in Belgium in 1981 and the Gross intake ratio(%) in Costa Rica in 1982?
Your response must be concise. -7.45. What is the difference between the Gross intake ratio(%) of Belgium in 1981 and the Gross intake ratio(%) of Togo in 1982?
Your answer should be compact. 5.64. What is the difference between the Gross intake ratio(%) of Brunei Darussalam in 1981 and the Gross intake ratio(%) of Costa Rica in 1982?
Your answer should be compact. -5.93. What is the difference between the Gross intake ratio(%) in Brunei Darussalam in 1981 and the Gross intake ratio(%) in Togo in 1982?
Provide a short and direct response. 7.15. What is the difference between the Gross intake ratio(%) of Costa Rica in 1981 and the Gross intake ratio(%) of Togo in 1982?
Your response must be concise. 21.89. What is the difference between the Gross intake ratio(%) in Belgium in 1981 and the Gross intake ratio(%) in Brunei Darussalam in 1986?
Provide a succinct answer. -8.78. What is the difference between the Gross intake ratio(%) in Belgium in 1981 and the Gross intake ratio(%) in Costa Rica in 1986?
Provide a succinct answer. -7.56. What is the difference between the Gross intake ratio(%) of Belgium in 1981 and the Gross intake ratio(%) of Togo in 1986?
Make the answer very short. 2.56. What is the difference between the Gross intake ratio(%) of Brunei Darussalam in 1981 and the Gross intake ratio(%) of Costa Rica in 1986?
Your answer should be very brief. -6.05. What is the difference between the Gross intake ratio(%) in Brunei Darussalam in 1981 and the Gross intake ratio(%) in Togo in 1986?
Give a very brief answer. 4.08. What is the difference between the Gross intake ratio(%) in Costa Rica in 1981 and the Gross intake ratio(%) in Togo in 1986?
Keep it short and to the point. 18.82. What is the difference between the Gross intake ratio(%) of Belgium in 1981 and the Gross intake ratio(%) of Brunei Darussalam in 2004?
Keep it short and to the point. -10.15. What is the difference between the Gross intake ratio(%) of Belgium in 1981 and the Gross intake ratio(%) of Costa Rica in 2004?
Ensure brevity in your answer.  -10.9. What is the difference between the Gross intake ratio(%) of Belgium in 1981 and the Gross intake ratio(%) of Togo in 2004?
Offer a very short reply. -3.56. What is the difference between the Gross intake ratio(%) of Brunei Darussalam in 1981 and the Gross intake ratio(%) of Costa Rica in 2004?
Provide a succinct answer. -9.38. What is the difference between the Gross intake ratio(%) of Brunei Darussalam in 1981 and the Gross intake ratio(%) of Togo in 2004?
Offer a very short reply. -2.04. What is the difference between the Gross intake ratio(%) of Costa Rica in 1981 and the Gross intake ratio(%) of Togo in 2004?
Your response must be concise. 12.69. What is the difference between the Gross intake ratio(%) in Belgium in 1981 and the Gross intake ratio(%) in Brunei Darussalam in 2006?
Provide a short and direct response. -13.18. What is the difference between the Gross intake ratio(%) in Belgium in 1981 and the Gross intake ratio(%) in Costa Rica in 2006?
Your response must be concise. -10.05. What is the difference between the Gross intake ratio(%) in Belgium in 1981 and the Gross intake ratio(%) in Togo in 2006?
Ensure brevity in your answer.  -16.78. What is the difference between the Gross intake ratio(%) in Brunei Darussalam in 1981 and the Gross intake ratio(%) in Costa Rica in 2006?
Give a very brief answer. -8.53. What is the difference between the Gross intake ratio(%) in Brunei Darussalam in 1981 and the Gross intake ratio(%) in Togo in 2006?
Ensure brevity in your answer.  -15.26. What is the difference between the Gross intake ratio(%) of Costa Rica in 1981 and the Gross intake ratio(%) of Togo in 2006?
Provide a short and direct response. -0.53. What is the difference between the Gross intake ratio(%) in Belgium in 1982 and the Gross intake ratio(%) in Brunei Darussalam in 1986?
Provide a short and direct response. -12.39. What is the difference between the Gross intake ratio(%) of Belgium in 1982 and the Gross intake ratio(%) of Costa Rica in 1986?
Keep it short and to the point. -11.17. What is the difference between the Gross intake ratio(%) of Belgium in 1982 and the Gross intake ratio(%) of Togo in 1986?
Provide a short and direct response. -1.04. What is the difference between the Gross intake ratio(%) in Brunei Darussalam in 1982 and the Gross intake ratio(%) in Costa Rica in 1986?
Provide a succinct answer. -14.93. What is the difference between the Gross intake ratio(%) in Brunei Darussalam in 1982 and the Gross intake ratio(%) in Togo in 1986?
Provide a short and direct response. -4.8. What is the difference between the Gross intake ratio(%) in Costa Rica in 1982 and the Gross intake ratio(%) in Togo in 1986?
Keep it short and to the point. 10.02. What is the difference between the Gross intake ratio(%) of Belgium in 1982 and the Gross intake ratio(%) of Brunei Darussalam in 2004?
Keep it short and to the point. -13.76. What is the difference between the Gross intake ratio(%) in Belgium in 1982 and the Gross intake ratio(%) in Costa Rica in 2004?
Ensure brevity in your answer.  -14.51. What is the difference between the Gross intake ratio(%) of Belgium in 1982 and the Gross intake ratio(%) of Togo in 2004?
Make the answer very short. -7.17. What is the difference between the Gross intake ratio(%) in Brunei Darussalam in 1982 and the Gross intake ratio(%) in Costa Rica in 2004?
Offer a very short reply. -18.27. What is the difference between the Gross intake ratio(%) in Brunei Darussalam in 1982 and the Gross intake ratio(%) in Togo in 2004?
Your response must be concise. -10.93. What is the difference between the Gross intake ratio(%) of Costa Rica in 1982 and the Gross intake ratio(%) of Togo in 2004?
Keep it short and to the point. 3.89. What is the difference between the Gross intake ratio(%) of Belgium in 1982 and the Gross intake ratio(%) of Brunei Darussalam in 2006?
Ensure brevity in your answer.  -16.78. What is the difference between the Gross intake ratio(%) in Belgium in 1982 and the Gross intake ratio(%) in Costa Rica in 2006?
Your answer should be very brief. -13.65. What is the difference between the Gross intake ratio(%) of Belgium in 1982 and the Gross intake ratio(%) of Togo in 2006?
Your answer should be compact. -20.39. What is the difference between the Gross intake ratio(%) in Brunei Darussalam in 1982 and the Gross intake ratio(%) in Costa Rica in 2006?
Ensure brevity in your answer.  -17.41. What is the difference between the Gross intake ratio(%) of Brunei Darussalam in 1982 and the Gross intake ratio(%) of Togo in 2006?
Your answer should be compact. -24.15. What is the difference between the Gross intake ratio(%) in Costa Rica in 1982 and the Gross intake ratio(%) in Togo in 2006?
Your answer should be compact. -9.33. What is the difference between the Gross intake ratio(%) in Belgium in 1986 and the Gross intake ratio(%) in Brunei Darussalam in 2004?
Provide a short and direct response. -9.51. What is the difference between the Gross intake ratio(%) of Belgium in 1986 and the Gross intake ratio(%) of Costa Rica in 2004?
Provide a short and direct response. -10.26. What is the difference between the Gross intake ratio(%) of Belgium in 1986 and the Gross intake ratio(%) of Togo in 2004?
Provide a succinct answer. -2.92. What is the difference between the Gross intake ratio(%) in Brunei Darussalam in 1986 and the Gross intake ratio(%) in Costa Rica in 2004?
Offer a very short reply. -2.12. What is the difference between the Gross intake ratio(%) of Brunei Darussalam in 1986 and the Gross intake ratio(%) of Togo in 2004?
Keep it short and to the point. 5.22. What is the difference between the Gross intake ratio(%) in Costa Rica in 1986 and the Gross intake ratio(%) in Togo in 2004?
Your answer should be very brief. 4. What is the difference between the Gross intake ratio(%) of Belgium in 1986 and the Gross intake ratio(%) of Brunei Darussalam in 2006?
Offer a very short reply. -12.53. What is the difference between the Gross intake ratio(%) of Belgium in 1986 and the Gross intake ratio(%) of Costa Rica in 2006?
Offer a very short reply. -9.4. What is the difference between the Gross intake ratio(%) of Belgium in 1986 and the Gross intake ratio(%) of Togo in 2006?
Give a very brief answer. -16.13. What is the difference between the Gross intake ratio(%) in Brunei Darussalam in 1986 and the Gross intake ratio(%) in Costa Rica in 2006?
Keep it short and to the point. -1.26. What is the difference between the Gross intake ratio(%) in Brunei Darussalam in 1986 and the Gross intake ratio(%) in Togo in 2006?
Your answer should be compact. -8. What is the difference between the Gross intake ratio(%) in Costa Rica in 1986 and the Gross intake ratio(%) in Togo in 2006?
Your answer should be very brief. -9.21. What is the difference between the Gross intake ratio(%) of Belgium in 2004 and the Gross intake ratio(%) of Brunei Darussalam in 2006?
Give a very brief answer. -15.36. What is the difference between the Gross intake ratio(%) of Belgium in 2004 and the Gross intake ratio(%) of Costa Rica in 2006?
Make the answer very short. -12.22. What is the difference between the Gross intake ratio(%) of Belgium in 2004 and the Gross intake ratio(%) of Togo in 2006?
Provide a succinct answer. -18.96. What is the difference between the Gross intake ratio(%) of Brunei Darussalam in 2004 and the Gross intake ratio(%) of Costa Rica in 2006?
Give a very brief answer. 0.11. What is the difference between the Gross intake ratio(%) of Brunei Darussalam in 2004 and the Gross intake ratio(%) of Togo in 2006?
Your response must be concise. -6.63. What is the difference between the Gross intake ratio(%) of Costa Rica in 2004 and the Gross intake ratio(%) of Togo in 2006?
Offer a terse response. -5.88. What is the average Gross intake ratio(%) in Belgium per year?
Keep it short and to the point. 99.44. What is the average Gross intake ratio(%) of Brunei Darussalam per year?
Provide a succinct answer. 95.16. What is the average Gross intake ratio(%) in Costa Rica per year?
Offer a terse response. 111.02. What is the average Gross intake ratio(%) of Togo per year?
Make the answer very short. 106.55. In the year 1978, what is the difference between the Gross intake ratio(%) in Belgium and Gross intake ratio(%) in Brunei Darussalam?
Your response must be concise. -1.28. In the year 1978, what is the difference between the Gross intake ratio(%) in Belgium and Gross intake ratio(%) in Costa Rica?
Make the answer very short. -13.26. In the year 1978, what is the difference between the Gross intake ratio(%) in Belgium and Gross intake ratio(%) in Togo?
Your answer should be compact. -8.96. In the year 1978, what is the difference between the Gross intake ratio(%) in Brunei Darussalam and Gross intake ratio(%) in Costa Rica?
Offer a terse response. -11.98. In the year 1978, what is the difference between the Gross intake ratio(%) in Brunei Darussalam and Gross intake ratio(%) in Togo?
Your answer should be compact. -7.68. In the year 1978, what is the difference between the Gross intake ratio(%) in Costa Rica and Gross intake ratio(%) in Togo?
Keep it short and to the point. 4.3. In the year 1979, what is the difference between the Gross intake ratio(%) of Belgium and Gross intake ratio(%) of Brunei Darussalam?
Make the answer very short. 69.78. In the year 1979, what is the difference between the Gross intake ratio(%) in Belgium and Gross intake ratio(%) in Costa Rica?
Ensure brevity in your answer.  -5.49. In the year 1979, what is the difference between the Gross intake ratio(%) in Belgium and Gross intake ratio(%) in Togo?
Provide a short and direct response. -15.22. In the year 1979, what is the difference between the Gross intake ratio(%) in Brunei Darussalam and Gross intake ratio(%) in Costa Rica?
Provide a short and direct response. -75.27. In the year 1979, what is the difference between the Gross intake ratio(%) of Brunei Darussalam and Gross intake ratio(%) of Togo?
Your answer should be compact. -85. In the year 1979, what is the difference between the Gross intake ratio(%) in Costa Rica and Gross intake ratio(%) in Togo?
Give a very brief answer. -9.72. In the year 1980, what is the difference between the Gross intake ratio(%) in Belgium and Gross intake ratio(%) in Brunei Darussalam?
Offer a very short reply. -1.7. In the year 1980, what is the difference between the Gross intake ratio(%) of Belgium and Gross intake ratio(%) of Costa Rica?
Provide a short and direct response. -15.41. In the year 1980, what is the difference between the Gross intake ratio(%) of Belgium and Gross intake ratio(%) of Togo?
Give a very brief answer. -10.05. In the year 1980, what is the difference between the Gross intake ratio(%) in Brunei Darussalam and Gross intake ratio(%) in Costa Rica?
Offer a terse response. -13.71. In the year 1980, what is the difference between the Gross intake ratio(%) in Brunei Darussalam and Gross intake ratio(%) in Togo?
Provide a short and direct response. -8.35. In the year 1980, what is the difference between the Gross intake ratio(%) of Costa Rica and Gross intake ratio(%) of Togo?
Provide a succinct answer. 5.36. In the year 1981, what is the difference between the Gross intake ratio(%) of Belgium and Gross intake ratio(%) of Brunei Darussalam?
Offer a terse response. -1.52. In the year 1981, what is the difference between the Gross intake ratio(%) of Belgium and Gross intake ratio(%) of Costa Rica?
Keep it short and to the point. -16.25. In the year 1981, what is the difference between the Gross intake ratio(%) in Belgium and Gross intake ratio(%) in Togo?
Offer a terse response. -4.25. In the year 1981, what is the difference between the Gross intake ratio(%) of Brunei Darussalam and Gross intake ratio(%) of Costa Rica?
Offer a terse response. -14.73. In the year 1981, what is the difference between the Gross intake ratio(%) of Brunei Darussalam and Gross intake ratio(%) of Togo?
Offer a very short reply. -2.73. In the year 1981, what is the difference between the Gross intake ratio(%) in Costa Rica and Gross intake ratio(%) in Togo?
Your answer should be very brief. 12. In the year 1982, what is the difference between the Gross intake ratio(%) in Belgium and Gross intake ratio(%) in Brunei Darussalam?
Offer a very short reply. 3.76. In the year 1982, what is the difference between the Gross intake ratio(%) of Belgium and Gross intake ratio(%) of Costa Rica?
Keep it short and to the point. -11.06. In the year 1982, what is the difference between the Gross intake ratio(%) in Belgium and Gross intake ratio(%) in Togo?
Offer a terse response. 2.03. In the year 1982, what is the difference between the Gross intake ratio(%) in Brunei Darussalam and Gross intake ratio(%) in Costa Rica?
Give a very brief answer. -14.82. In the year 1982, what is the difference between the Gross intake ratio(%) of Brunei Darussalam and Gross intake ratio(%) of Togo?
Make the answer very short. -1.73. In the year 1982, what is the difference between the Gross intake ratio(%) in Costa Rica and Gross intake ratio(%) in Togo?
Your response must be concise. 13.09. In the year 1986, what is the difference between the Gross intake ratio(%) in Belgium and Gross intake ratio(%) in Brunei Darussalam?
Your answer should be very brief. -8.14. In the year 1986, what is the difference between the Gross intake ratio(%) in Belgium and Gross intake ratio(%) in Costa Rica?
Offer a very short reply. -6.92. In the year 1986, what is the difference between the Gross intake ratio(%) in Belgium and Gross intake ratio(%) in Togo?
Your response must be concise. 3.21. In the year 1986, what is the difference between the Gross intake ratio(%) in Brunei Darussalam and Gross intake ratio(%) in Costa Rica?
Ensure brevity in your answer.  1.22. In the year 1986, what is the difference between the Gross intake ratio(%) in Brunei Darussalam and Gross intake ratio(%) in Togo?
Ensure brevity in your answer.  11.35. In the year 1986, what is the difference between the Gross intake ratio(%) of Costa Rica and Gross intake ratio(%) of Togo?
Offer a very short reply. 10.13. In the year 2004, what is the difference between the Gross intake ratio(%) in Belgium and Gross intake ratio(%) in Brunei Darussalam?
Keep it short and to the point. -12.33. In the year 2004, what is the difference between the Gross intake ratio(%) of Belgium and Gross intake ratio(%) of Costa Rica?
Provide a succinct answer. -13.08. In the year 2004, what is the difference between the Gross intake ratio(%) in Belgium and Gross intake ratio(%) in Togo?
Offer a terse response. -5.74. In the year 2004, what is the difference between the Gross intake ratio(%) in Brunei Darussalam and Gross intake ratio(%) in Costa Rica?
Provide a succinct answer. -0.75. In the year 2004, what is the difference between the Gross intake ratio(%) of Brunei Darussalam and Gross intake ratio(%) of Togo?
Give a very brief answer. 6.59. In the year 2004, what is the difference between the Gross intake ratio(%) in Costa Rica and Gross intake ratio(%) in Togo?
Provide a succinct answer. 7.34. In the year 2006, what is the difference between the Gross intake ratio(%) in Belgium and Gross intake ratio(%) in Brunei Darussalam?
Offer a very short reply. -14.3. In the year 2006, what is the difference between the Gross intake ratio(%) in Belgium and Gross intake ratio(%) in Costa Rica?
Provide a short and direct response. -11.17. In the year 2006, what is the difference between the Gross intake ratio(%) of Belgium and Gross intake ratio(%) of Togo?
Offer a terse response. -17.9. In the year 2006, what is the difference between the Gross intake ratio(%) of Brunei Darussalam and Gross intake ratio(%) of Costa Rica?
Provide a short and direct response. 3.13. In the year 2006, what is the difference between the Gross intake ratio(%) of Brunei Darussalam and Gross intake ratio(%) of Togo?
Give a very brief answer. -3.6. In the year 2006, what is the difference between the Gross intake ratio(%) in Costa Rica and Gross intake ratio(%) in Togo?
Keep it short and to the point. -6.73. What is the ratio of the Gross intake ratio(%) of Brunei Darussalam in 1978 to that in 1979?
Keep it short and to the point. 3.08. What is the ratio of the Gross intake ratio(%) in Costa Rica in 1978 to that in 1979?
Give a very brief answer. 1.06. What is the ratio of the Gross intake ratio(%) of Togo in 1978 to that in 1979?
Offer a terse response. 0.94. What is the ratio of the Gross intake ratio(%) in Belgium in 1978 to that in 1980?
Provide a succinct answer. 1.02. What is the ratio of the Gross intake ratio(%) in Brunei Darussalam in 1978 to that in 1980?
Your response must be concise. 1.01. What is the ratio of the Gross intake ratio(%) in Togo in 1978 to that in 1980?
Provide a succinct answer. 1.01. What is the ratio of the Gross intake ratio(%) in Belgium in 1978 to that in 1981?
Offer a terse response. 1.04. What is the ratio of the Gross intake ratio(%) in Brunei Darussalam in 1978 to that in 1981?
Make the answer very short. 1.03. What is the ratio of the Gross intake ratio(%) in Costa Rica in 1978 to that in 1981?
Provide a short and direct response. 1.01. What is the ratio of the Gross intake ratio(%) in Togo in 1978 to that in 1981?
Make the answer very short. 1.08. What is the ratio of the Gross intake ratio(%) in Belgium in 1978 to that in 1982?
Make the answer very short. 1.08. What is the ratio of the Gross intake ratio(%) of Brunei Darussalam in 1978 to that in 1982?
Your response must be concise. 1.13. What is the ratio of the Gross intake ratio(%) in Costa Rica in 1978 to that in 1982?
Offer a very short reply. 1.09. What is the ratio of the Gross intake ratio(%) in Togo in 1978 to that in 1982?
Offer a very short reply. 1.2. What is the ratio of the Gross intake ratio(%) in Belgium in 1978 to that in 1986?
Give a very brief answer. 1.03. What is the ratio of the Gross intake ratio(%) in Brunei Darussalam in 1978 to that in 1986?
Provide a succinct answer. 0.96. What is the ratio of the Gross intake ratio(%) in Costa Rica in 1978 to that in 1986?
Your response must be concise. 1.09. What is the ratio of the Gross intake ratio(%) in Togo in 1978 to that in 1986?
Offer a terse response. 1.16. What is the ratio of the Gross intake ratio(%) in Belgium in 1978 to that in 2004?
Your response must be concise. 1.06. What is the ratio of the Gross intake ratio(%) of Brunei Darussalam in 1978 to that in 2004?
Make the answer very short. 0.95. What is the ratio of the Gross intake ratio(%) of Costa Rica in 1978 to that in 2004?
Your answer should be very brief. 1.06. What is the ratio of the Gross intake ratio(%) of Togo in 1978 to that in 2004?
Make the answer very short. 1.09. What is the ratio of the Gross intake ratio(%) in Belgium in 1978 to that in 2006?
Offer a terse response. 1.05. What is the ratio of the Gross intake ratio(%) in Brunei Darussalam in 1978 to that in 2006?
Your answer should be very brief. 0.93. What is the ratio of the Gross intake ratio(%) of Costa Rica in 1978 to that in 2006?
Your answer should be compact. 1.06. What is the ratio of the Gross intake ratio(%) of Togo in 1978 to that in 2006?
Make the answer very short. 0.96. What is the ratio of the Gross intake ratio(%) in Belgium in 1979 to that in 1980?
Ensure brevity in your answer.  1.03. What is the ratio of the Gross intake ratio(%) in Brunei Darussalam in 1979 to that in 1980?
Offer a very short reply. 0.33. What is the ratio of the Gross intake ratio(%) of Costa Rica in 1979 to that in 1980?
Ensure brevity in your answer.  0.94. What is the ratio of the Gross intake ratio(%) of Togo in 1979 to that in 1980?
Your answer should be very brief. 1.07. What is the ratio of the Gross intake ratio(%) of Belgium in 1979 to that in 1981?
Ensure brevity in your answer.  1.05. What is the ratio of the Gross intake ratio(%) in Brunei Darussalam in 1979 to that in 1981?
Provide a short and direct response. 0.34. What is the ratio of the Gross intake ratio(%) of Costa Rica in 1979 to that in 1981?
Your answer should be compact. 0.95. What is the ratio of the Gross intake ratio(%) of Togo in 1979 to that in 1981?
Keep it short and to the point. 1.15. What is the ratio of the Gross intake ratio(%) in Belgium in 1979 to that in 1982?
Provide a short and direct response. 1.09. What is the ratio of the Gross intake ratio(%) of Brunei Darussalam in 1979 to that in 1982?
Offer a very short reply. 0.37. What is the ratio of the Gross intake ratio(%) in Togo in 1979 to that in 1982?
Your answer should be very brief. 1.27. What is the ratio of the Gross intake ratio(%) of Belgium in 1979 to that in 1986?
Your answer should be very brief. 1.04. What is the ratio of the Gross intake ratio(%) in Brunei Darussalam in 1979 to that in 1986?
Give a very brief answer. 0.31. What is the ratio of the Gross intake ratio(%) in Costa Rica in 1979 to that in 1986?
Make the answer very short. 1.02. What is the ratio of the Gross intake ratio(%) in Togo in 1979 to that in 1986?
Provide a short and direct response. 1.23. What is the ratio of the Gross intake ratio(%) in Belgium in 1979 to that in 2004?
Your answer should be compact. 1.07. What is the ratio of the Gross intake ratio(%) in Brunei Darussalam in 1979 to that in 2004?
Offer a very short reply. 0.31. What is the ratio of the Gross intake ratio(%) in Togo in 1979 to that in 2004?
Ensure brevity in your answer.  1.16. What is the ratio of the Gross intake ratio(%) of Belgium in 1979 to that in 2006?
Provide a succinct answer. 1.06. What is the ratio of the Gross intake ratio(%) in Brunei Darussalam in 1979 to that in 2006?
Make the answer very short. 0.3. What is the ratio of the Gross intake ratio(%) in Togo in 1979 to that in 2006?
Your answer should be very brief. 1.03. What is the ratio of the Gross intake ratio(%) of Belgium in 1980 to that in 1981?
Your answer should be compact. 1.02. What is the ratio of the Gross intake ratio(%) in Brunei Darussalam in 1980 to that in 1981?
Make the answer very short. 1.02. What is the ratio of the Gross intake ratio(%) of Costa Rica in 1980 to that in 1981?
Offer a very short reply. 1.01. What is the ratio of the Gross intake ratio(%) in Togo in 1980 to that in 1981?
Offer a terse response. 1.07. What is the ratio of the Gross intake ratio(%) of Belgium in 1980 to that in 1982?
Give a very brief answer. 1.06. What is the ratio of the Gross intake ratio(%) in Brunei Darussalam in 1980 to that in 1982?
Offer a terse response. 1.12. What is the ratio of the Gross intake ratio(%) in Costa Rica in 1980 to that in 1982?
Offer a very short reply. 1.09. What is the ratio of the Gross intake ratio(%) of Togo in 1980 to that in 1982?
Make the answer very short. 1.19. What is the ratio of the Gross intake ratio(%) of Belgium in 1980 to that in 1986?
Make the answer very short. 1.01. What is the ratio of the Gross intake ratio(%) of Brunei Darussalam in 1980 to that in 1986?
Provide a short and direct response. 0.95. What is the ratio of the Gross intake ratio(%) in Costa Rica in 1980 to that in 1986?
Offer a terse response. 1.09. What is the ratio of the Gross intake ratio(%) in Togo in 1980 to that in 1986?
Give a very brief answer. 1.15. What is the ratio of the Gross intake ratio(%) of Belgium in 1980 to that in 2004?
Offer a terse response. 1.04. What is the ratio of the Gross intake ratio(%) in Brunei Darussalam in 1980 to that in 2004?
Your answer should be compact. 0.94. What is the ratio of the Gross intake ratio(%) in Costa Rica in 1980 to that in 2004?
Give a very brief answer. 1.06. What is the ratio of the Gross intake ratio(%) in Togo in 1980 to that in 2004?
Your answer should be compact. 1.08. What is the ratio of the Gross intake ratio(%) in Belgium in 1980 to that in 2006?
Offer a very short reply. 1.03. What is the ratio of the Gross intake ratio(%) of Brunei Darussalam in 1980 to that in 2006?
Your answer should be very brief. 0.91. What is the ratio of the Gross intake ratio(%) in Costa Rica in 1980 to that in 2006?
Offer a terse response. 1.07. What is the ratio of the Gross intake ratio(%) in Togo in 1980 to that in 2006?
Provide a short and direct response. 0.96. What is the ratio of the Gross intake ratio(%) in Belgium in 1981 to that in 1982?
Ensure brevity in your answer.  1.04. What is the ratio of the Gross intake ratio(%) of Brunei Darussalam in 1981 to that in 1982?
Your response must be concise. 1.1. What is the ratio of the Gross intake ratio(%) of Costa Rica in 1981 to that in 1982?
Your answer should be very brief. 1.08. What is the ratio of the Gross intake ratio(%) in Togo in 1981 to that in 1982?
Offer a very short reply. 1.11. What is the ratio of the Gross intake ratio(%) in Belgium in 1981 to that in 1986?
Your answer should be compact. 0.99. What is the ratio of the Gross intake ratio(%) of Brunei Darussalam in 1981 to that in 1986?
Make the answer very short. 0.93. What is the ratio of the Gross intake ratio(%) in Costa Rica in 1981 to that in 1986?
Offer a very short reply. 1.08. What is the ratio of the Gross intake ratio(%) in Togo in 1981 to that in 1986?
Provide a short and direct response. 1.07. What is the ratio of the Gross intake ratio(%) in Belgium in 1981 to that in 2004?
Your response must be concise. 1.02. What is the ratio of the Gross intake ratio(%) in Brunei Darussalam in 1981 to that in 2004?
Offer a very short reply. 0.92. What is the ratio of the Gross intake ratio(%) in Costa Rica in 1981 to that in 2004?
Provide a succinct answer. 1.05. What is the ratio of the Gross intake ratio(%) of Belgium in 1981 to that in 2006?
Your answer should be very brief. 1.01. What is the ratio of the Gross intake ratio(%) in Brunei Darussalam in 1981 to that in 2006?
Keep it short and to the point. 0.9. What is the ratio of the Gross intake ratio(%) of Costa Rica in 1981 to that in 2006?
Offer a very short reply. 1.06. What is the ratio of the Gross intake ratio(%) of Togo in 1981 to that in 2006?
Ensure brevity in your answer.  0.89. What is the ratio of the Gross intake ratio(%) of Belgium in 1982 to that in 1986?
Provide a short and direct response. 0.96. What is the ratio of the Gross intake ratio(%) of Brunei Darussalam in 1982 to that in 1986?
Give a very brief answer. 0.85. What is the ratio of the Gross intake ratio(%) in Costa Rica in 1982 to that in 1986?
Keep it short and to the point. 1. What is the ratio of the Gross intake ratio(%) of Togo in 1982 to that in 1986?
Give a very brief answer. 0.97. What is the ratio of the Gross intake ratio(%) of Belgium in 1982 to that in 2004?
Give a very brief answer. 0.99. What is the ratio of the Gross intake ratio(%) in Brunei Darussalam in 1982 to that in 2004?
Keep it short and to the point. 0.84. What is the ratio of the Gross intake ratio(%) of Costa Rica in 1982 to that in 2004?
Provide a short and direct response. 0.97. What is the ratio of the Gross intake ratio(%) in Togo in 1982 to that in 2004?
Provide a short and direct response. 0.91. What is the ratio of the Gross intake ratio(%) in Belgium in 1982 to that in 2006?
Ensure brevity in your answer.  0.97. What is the ratio of the Gross intake ratio(%) of Brunei Darussalam in 1982 to that in 2006?
Give a very brief answer. 0.82. What is the ratio of the Gross intake ratio(%) of Costa Rica in 1982 to that in 2006?
Your response must be concise. 0.98. What is the ratio of the Gross intake ratio(%) in Togo in 1982 to that in 2006?
Make the answer very short. 0.81. What is the ratio of the Gross intake ratio(%) of Belgium in 1986 to that in 2004?
Provide a succinct answer. 1.03. What is the ratio of the Gross intake ratio(%) in Brunei Darussalam in 1986 to that in 2004?
Provide a succinct answer. 0.99. What is the ratio of the Gross intake ratio(%) in Costa Rica in 1986 to that in 2004?
Offer a terse response. 0.97. What is the ratio of the Gross intake ratio(%) of Togo in 1986 to that in 2004?
Your answer should be very brief. 0.94. What is the ratio of the Gross intake ratio(%) in Belgium in 1986 to that in 2006?
Provide a succinct answer. 1.02. What is the ratio of the Gross intake ratio(%) in Brunei Darussalam in 1986 to that in 2006?
Keep it short and to the point. 0.96. What is the ratio of the Gross intake ratio(%) in Costa Rica in 1986 to that in 2006?
Your response must be concise. 0.98. What is the ratio of the Gross intake ratio(%) in Togo in 1986 to that in 2006?
Make the answer very short. 0.83. What is the ratio of the Gross intake ratio(%) in Belgium in 2004 to that in 2006?
Keep it short and to the point. 0.99. What is the ratio of the Gross intake ratio(%) of Brunei Darussalam in 2004 to that in 2006?
Keep it short and to the point. 0.97. What is the ratio of the Gross intake ratio(%) in Costa Rica in 2004 to that in 2006?
Your response must be concise. 1.01. What is the ratio of the Gross intake ratio(%) of Togo in 2004 to that in 2006?
Your response must be concise. 0.89. What is the difference between the highest and the second highest Gross intake ratio(%) of Belgium?
Ensure brevity in your answer.  0.91. What is the difference between the highest and the second highest Gross intake ratio(%) in Brunei Darussalam?
Provide a short and direct response. 3.03. What is the difference between the highest and the second highest Gross intake ratio(%) in Costa Rica?
Your answer should be compact. 0.25. What is the difference between the highest and the second highest Gross intake ratio(%) of Togo?
Offer a very short reply. 3.05. What is the difference between the highest and the lowest Gross intake ratio(%) of Belgium?
Ensure brevity in your answer.  8.22. What is the difference between the highest and the lowest Gross intake ratio(%) in Brunei Darussalam?
Give a very brief answer. 78.34. What is the difference between the highest and the lowest Gross intake ratio(%) in Costa Rica?
Your answer should be very brief. 9.76. What is the difference between the highest and the lowest Gross intake ratio(%) in Togo?
Your response must be concise. 25.47. 